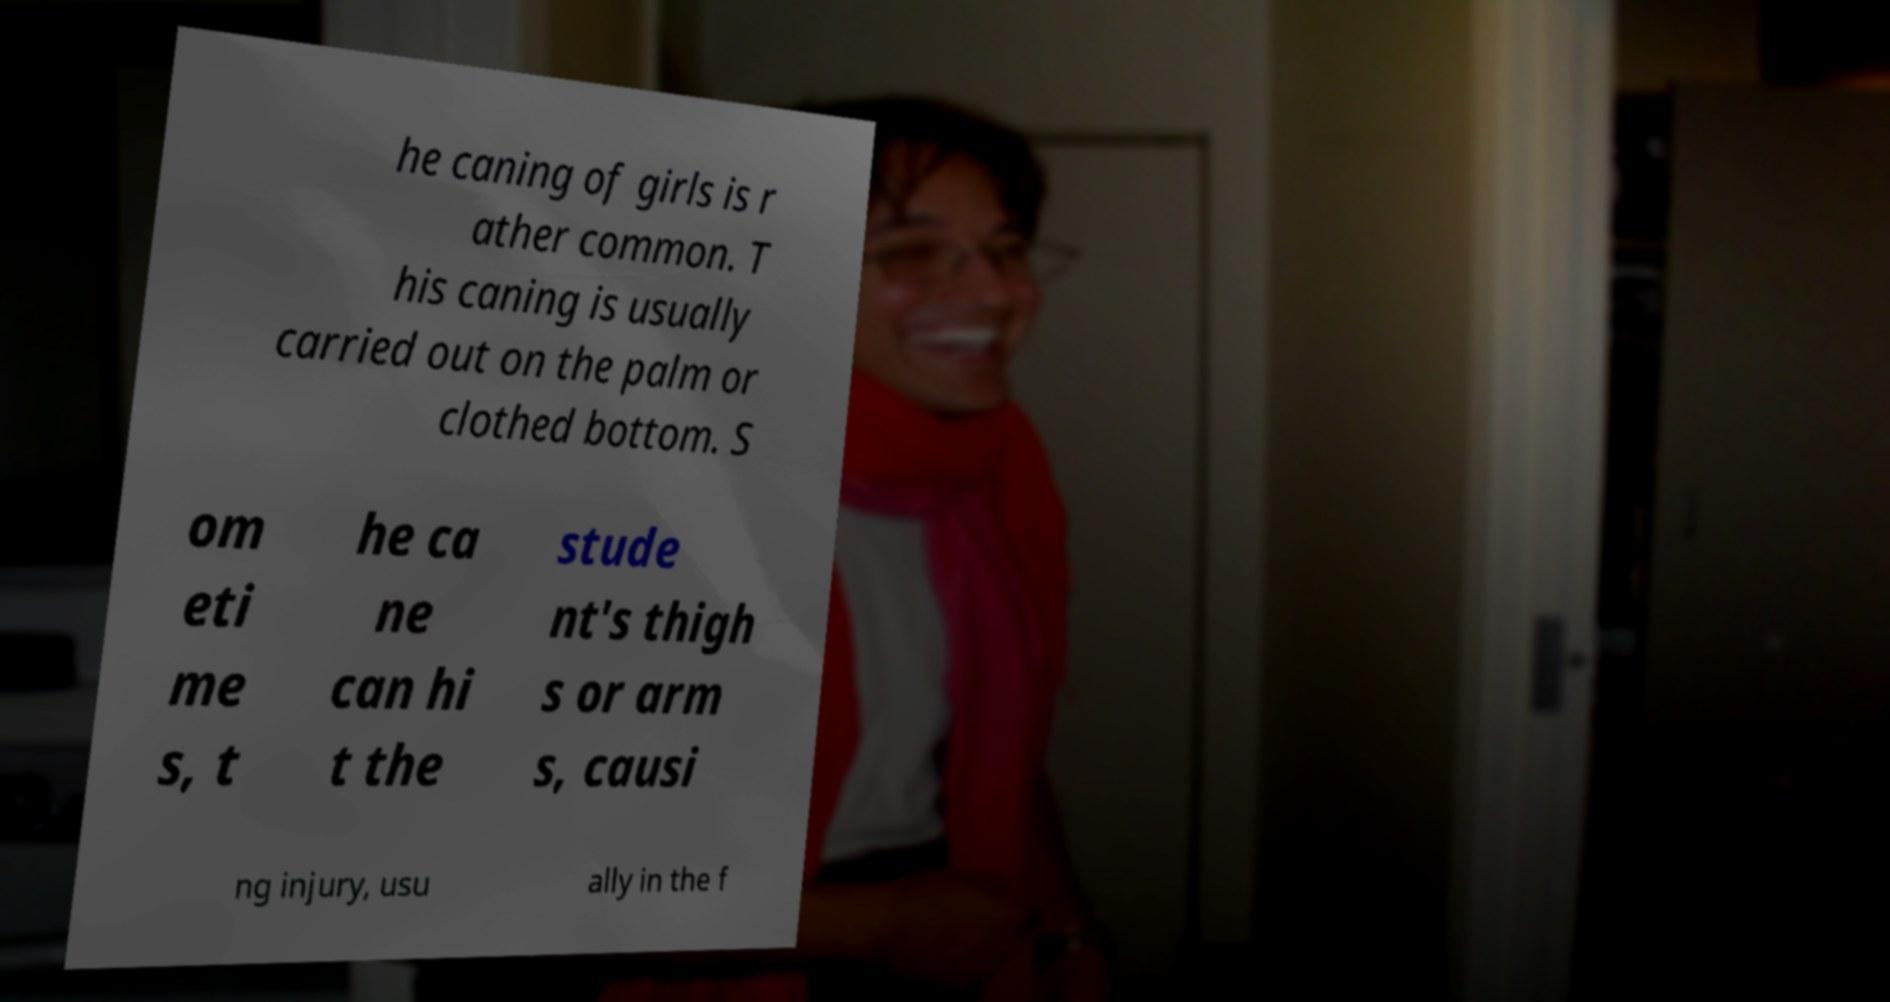I need the written content from this picture converted into text. Can you do that? he caning of girls is r ather common. T his caning is usually carried out on the palm or clothed bottom. S om eti me s, t he ca ne can hi t the stude nt's thigh s or arm s, causi ng injury, usu ally in the f 